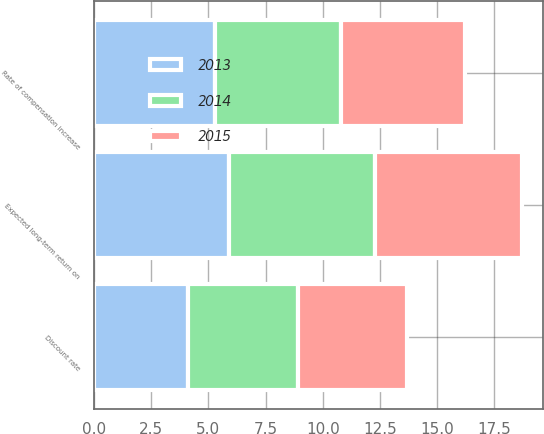Convert chart to OTSL. <chart><loc_0><loc_0><loc_500><loc_500><stacked_bar_chart><ecel><fcel>Discount rate<fcel>Expected long-term return on<fcel>Rate of compensation increase<nl><fcel>2013<fcel>4.1<fcel>5.9<fcel>5.3<nl><fcel>2015<fcel>4.8<fcel>6.4<fcel>5.4<nl><fcel>2014<fcel>4.8<fcel>6.4<fcel>5.5<nl></chart> 